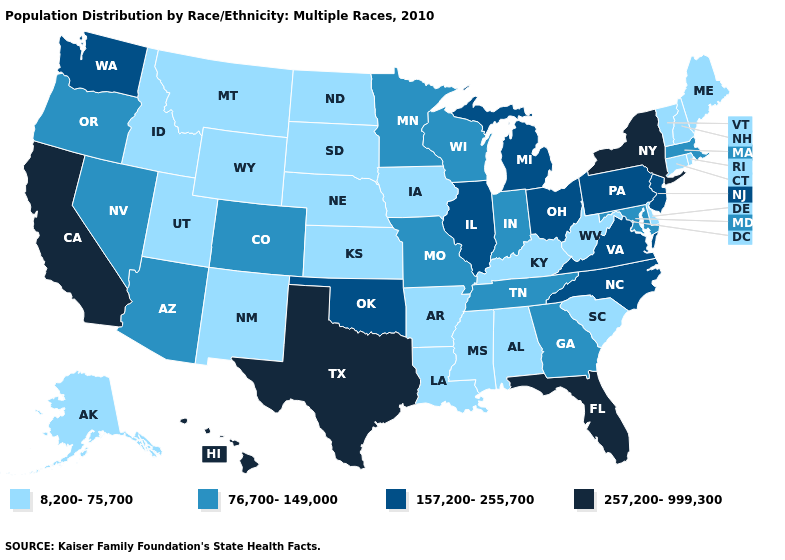Among the states that border Iowa , which have the lowest value?
Give a very brief answer. Nebraska, South Dakota. What is the value of Louisiana?
Write a very short answer. 8,200-75,700. Name the states that have a value in the range 76,700-149,000?
Keep it brief. Arizona, Colorado, Georgia, Indiana, Maryland, Massachusetts, Minnesota, Missouri, Nevada, Oregon, Tennessee, Wisconsin. Is the legend a continuous bar?
Keep it brief. No. What is the value of Connecticut?
Give a very brief answer. 8,200-75,700. Among the states that border Rhode Island , which have the lowest value?
Keep it brief. Connecticut. Name the states that have a value in the range 76,700-149,000?
Answer briefly. Arizona, Colorado, Georgia, Indiana, Maryland, Massachusetts, Minnesota, Missouri, Nevada, Oregon, Tennessee, Wisconsin. What is the value of Vermont?
Quick response, please. 8,200-75,700. What is the value of Wyoming?
Keep it brief. 8,200-75,700. What is the highest value in the USA?
Short answer required. 257,200-999,300. Among the states that border Indiana , which have the lowest value?
Concise answer only. Kentucky. Name the states that have a value in the range 257,200-999,300?
Short answer required. California, Florida, Hawaii, New York, Texas. What is the highest value in states that border New Mexico?
Keep it brief. 257,200-999,300. What is the highest value in the West ?
Keep it brief. 257,200-999,300. What is the value of Vermont?
Answer briefly. 8,200-75,700. 